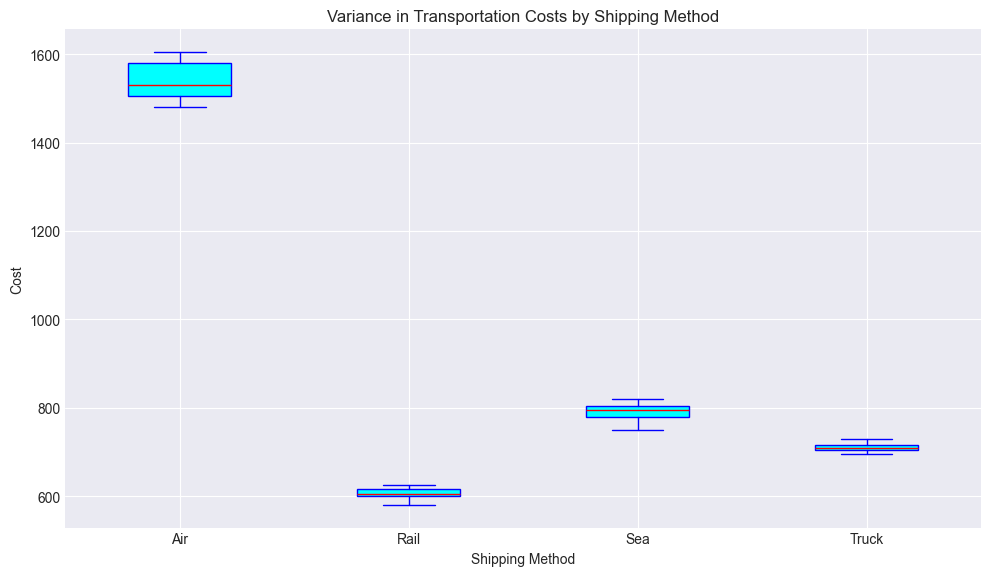What is the median cost for shipping by Air? To find the median cost for Air, we look for the line that cuts the box in half within the box plot for the 'Air' shipping method.
Answer: 1530 Which shipping method has the highest median cost? By comparing the median lines across all shipping methods, the Air method has the highest median line.
Answer: Air What is the range of costs for shipping by Sea? The range is determined by the distance between the bottom and top whiskers in the box plot for Sea. It spans from the lowest value (750) to the highest value (820). To find the range, subtract 750 from 820.
Answer: 70 Which shipping method exhibits the greatest variability in costs? Variability can be seen in the spread of the box and whiskers. The Air method shows the widest box and whiskers, indicating the greatest variability.
Answer: Air Are the costs more consistent for Rail or Truck? Consistency is seen in the compactness of the box plot. Comparing Rail and Truck, Rail has a narrower box and smaller whiskers, indicating more consistent costs.
Answer: Rail What does the red line in each box represent? The red line inside each box plot represents the median cost for that shipping method. The median is the middle value that separates the higher half from the lower half of the data.
Answer: Median cost Compare the interquartile range (IQR) between Air and Sea shipping methods. The IQR is the length of the boxplot, representing the middle 50% of the data. Air has a larger IQR than Sea, indicating a wider spread of the middle 50% of its costs.
Answer: Air has a larger IQR Which two shipping methods have the closest median costs? By examining the median lines (red lines), Truck and Rail have median lines that are very close to each other, indicating similar median costs.
Answer: Truck and Rail What can you infer about outliers in the plot? Outliers are indicated by red circles outside the whiskers. The presence of red circles in Air and Sea indicates that they have outliers in their cost data.
Answer: Air and Sea have outliers How do the maximum costs compare between Rail and Truck? The maximum cost is given by the top whisker. Comparing the top whiskers of Rail and Truck, Truck has a higher maximum cost.
Answer: Truck 